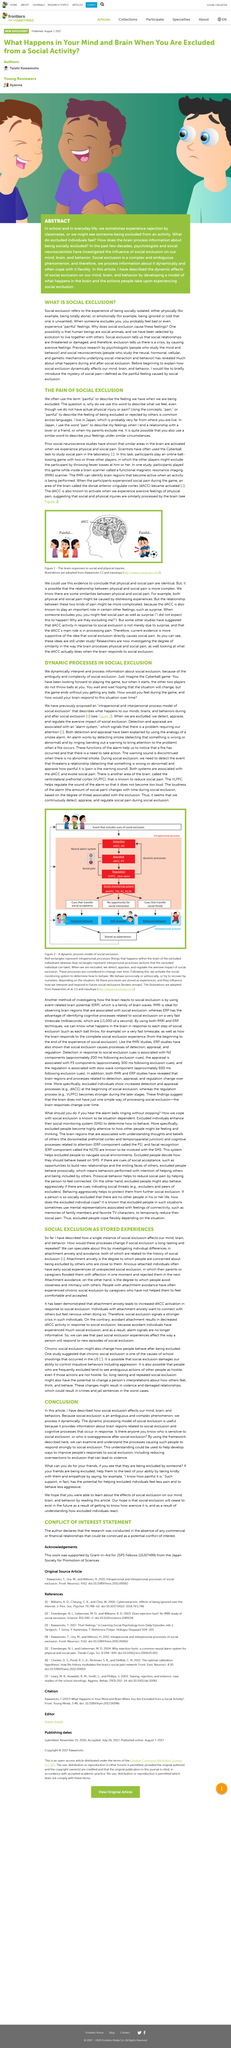Specify some key components in this picture. Chronic social exclusion is a possible cause of school shootings in the United States, as indicated by a study that suggests it as one of the factors contributing to these tragic incidents. Functional Magnetic Resonance Imaging, commonly referred to as fMRI, is a non-invasive imaging technique used to measure changes in blood flow in the brain, which can provide insights into brain activity and function. Intrapersonal processes refer to internal mental and emotional experiences that occur within the brain of an excluded individual. Scientists use the Cyberball task to study social pain in the laboratory. Attachment anxiety leads to increased dorsolateral prefrontal cortex (dACC) activation in response to social exclusion, as demonstrated by research. 